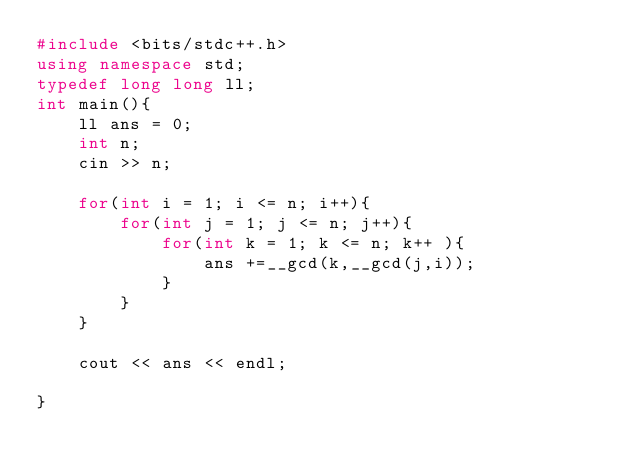Convert code to text. <code><loc_0><loc_0><loc_500><loc_500><_C++_>#include <bits/stdc++.h>
using namespace std;
typedef long long ll;
int main(){
    ll ans = 0;
    int n;
    cin >> n;

    for(int i = 1; i <= n; i++){
        for(int j = 1; j <= n; j++){
            for(int k = 1; k <= n; k++ ){
                ans +=__gcd(k,__gcd(j,i));
            }
        }
    }

    cout << ans << endl;
    
}
</code> 